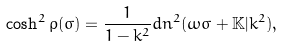Convert formula to latex. <formula><loc_0><loc_0><loc_500><loc_500>\cosh ^ { 2 } \rho ( \sigma ) = \frac { 1 } { 1 - k ^ { 2 } } d n ^ { 2 } ( \omega \sigma + \mathbb { K } | k ^ { 2 } ) ,</formula> 